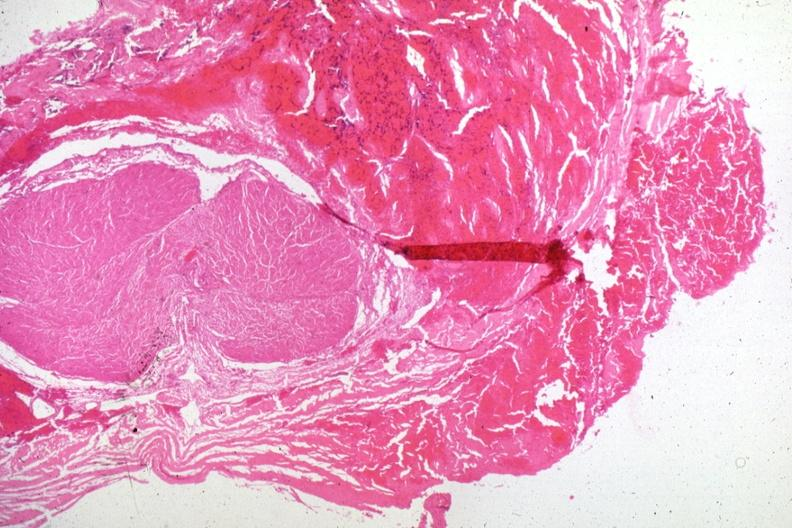what is present?
Answer the question using a single word or phrase. Malignant adenoma 